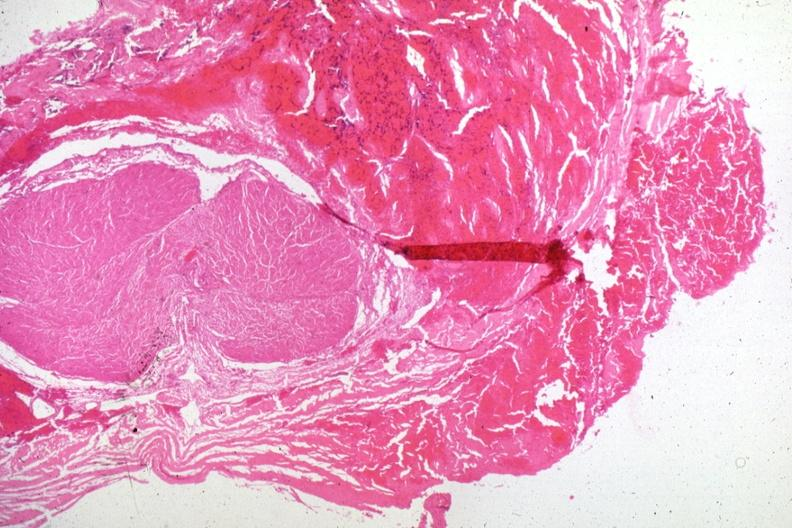what is present?
Answer the question using a single word or phrase. Malignant adenoma 